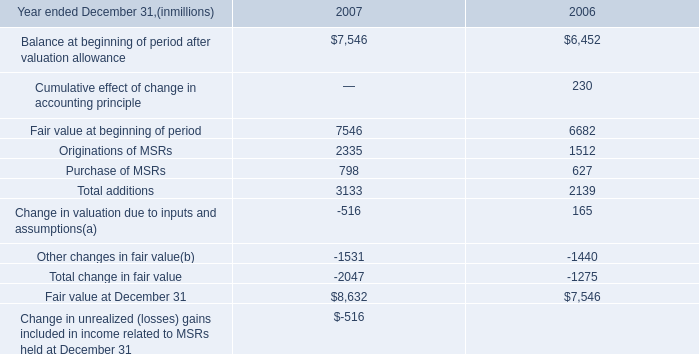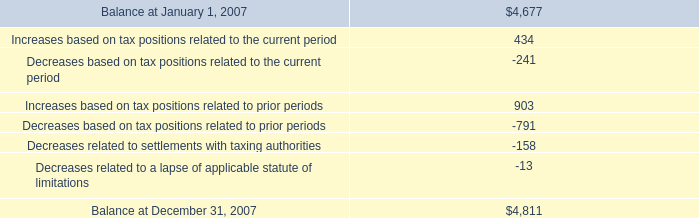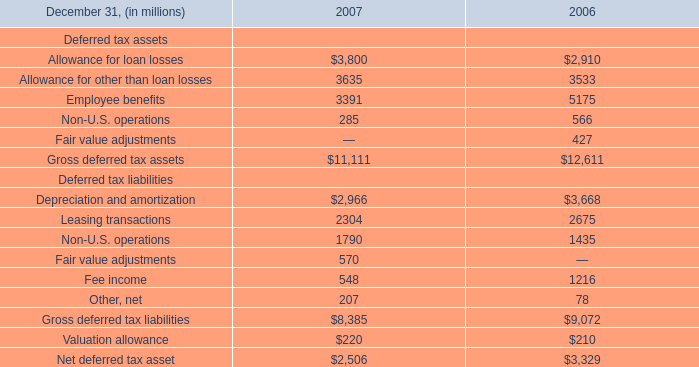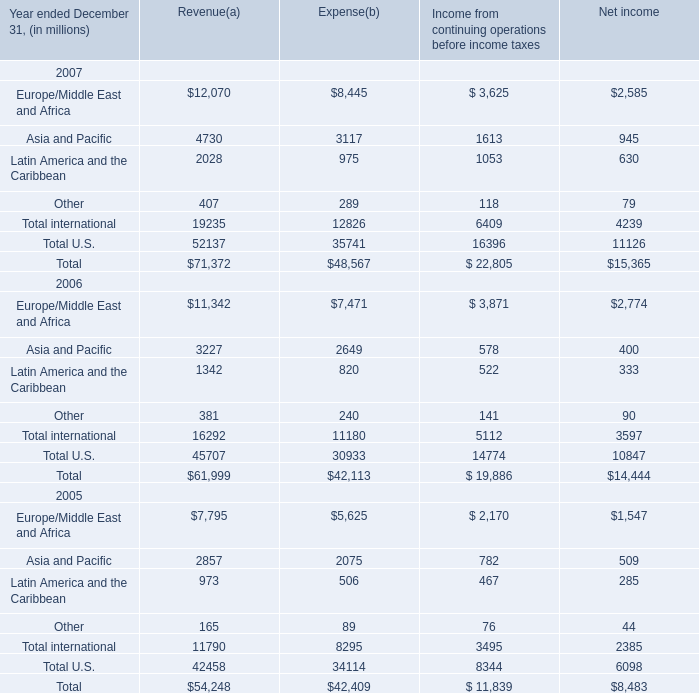What is the average value of Non-U.S. operations for Deferred tax assets and Increases based on tax positions related to prior periods in 2007? (in million) 
Computations: ((903 + 285) / 2)
Answer: 594.0. 